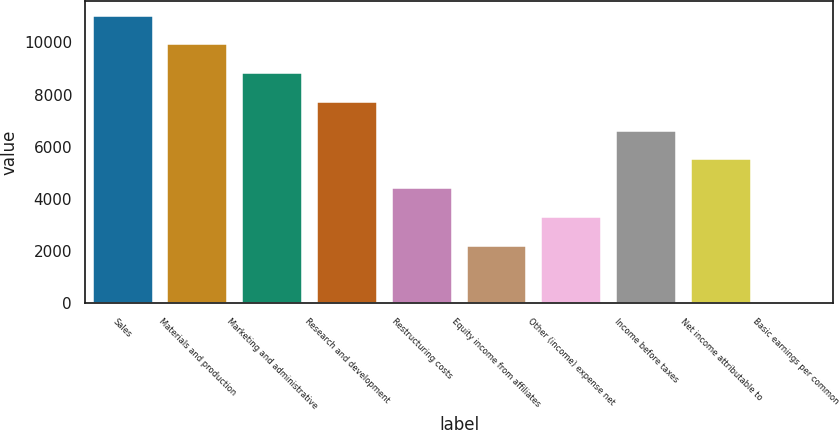Convert chart. <chart><loc_0><loc_0><loc_500><loc_500><bar_chart><fcel>Sales<fcel>Materials and production<fcel>Marketing and administrative<fcel>Research and development<fcel>Restructuring costs<fcel>Equity income from affiliates<fcel>Other (income) expense net<fcel>Income before taxes<fcel>Net income attributable to<fcel>Basic earnings per common<nl><fcel>11032<fcel>9928.82<fcel>8825.66<fcel>7722.5<fcel>4413.02<fcel>2206.7<fcel>3309.86<fcel>6619.34<fcel>5516.18<fcel>0.38<nl></chart> 